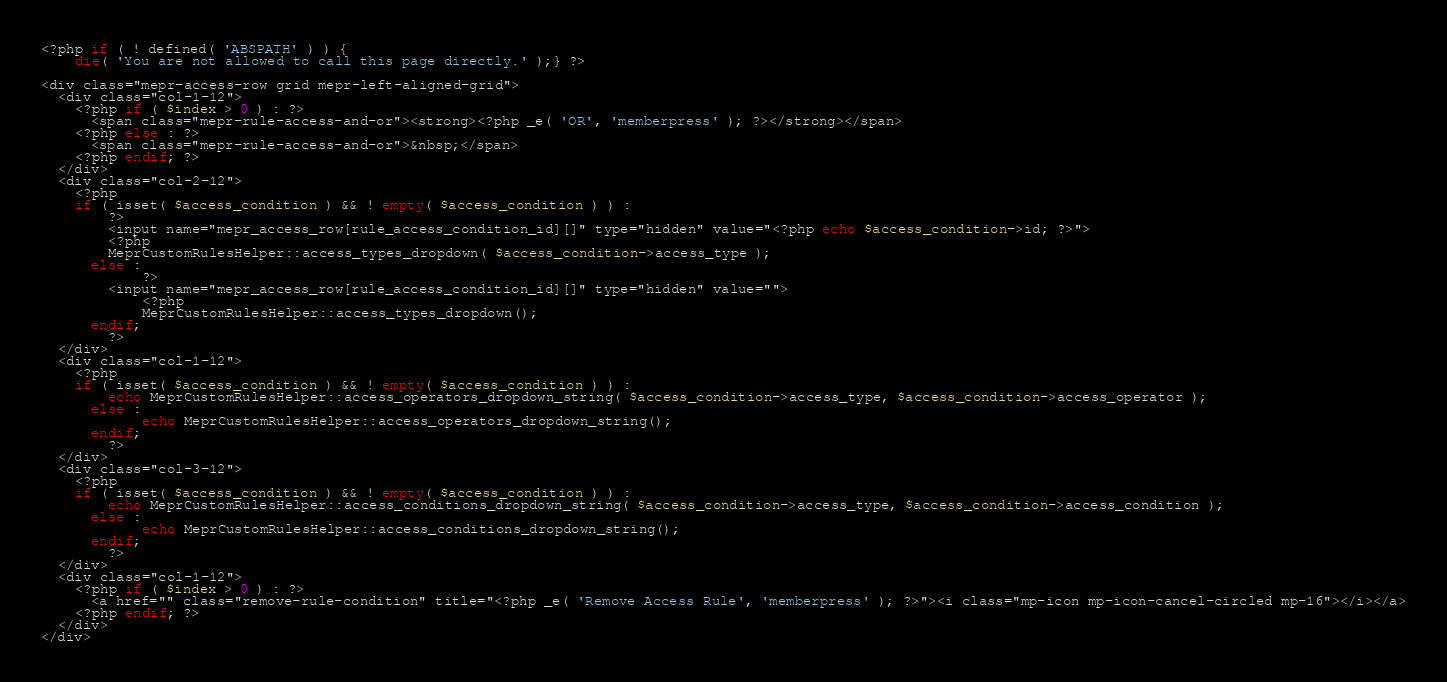<code> <loc_0><loc_0><loc_500><loc_500><_PHP_><?php if ( ! defined( 'ABSPATH' ) ) {
	die( 'You are not allowed to call this page directly.' );} ?>

<div class="mepr-access-row grid mepr-left-aligned-grid">
  <div class="col-1-12">
	<?php if ( $index > 0 ) : ?>
	  <span class="mepr-rule-access-and-or"><strong><?php _e( 'OR', 'memberpress' ); ?></strong></span>
	<?php else : ?>
	  <span class="mepr-rule-access-and-or">&nbsp;</span>
	<?php endif; ?>
  </div>
  <div class="col-2-12">
	<?php
	if ( isset( $access_condition ) && ! empty( $access_condition ) ) :
		?>
		<input name="mepr_access_row[rule_access_condition_id][]" type="hidden" value="<?php echo $access_condition->id; ?>">
		<?php
		MeprCustomRulesHelper::access_types_dropdown( $access_condition->access_type );
	  else :
			?>
		<input name="mepr_access_row[rule_access_condition_id][]" type="hidden" value="">
			<?php
			MeprCustomRulesHelper::access_types_dropdown();
	  endif;
		?>
  </div>
  <div class="col-1-12">
	<?php
	if ( isset( $access_condition ) && ! empty( $access_condition ) ) :
		echo MeprCustomRulesHelper::access_operators_dropdown_string( $access_condition->access_type, $access_condition->access_operator );
	  else :
			echo MeprCustomRulesHelper::access_operators_dropdown_string();
	  endif;
		?>
  </div>
  <div class="col-3-12">
	<?php
	if ( isset( $access_condition ) && ! empty( $access_condition ) ) :
		echo MeprCustomRulesHelper::access_conditions_dropdown_string( $access_condition->access_type, $access_condition->access_condition );
	  else :
			echo MeprCustomRulesHelper::access_conditions_dropdown_string();
	  endif;
		?>
  </div>
  <div class="col-1-12">
	<?php if ( $index > 0 ) : ?>
	  <a href="" class="remove-rule-condition" title="<?php _e( 'Remove Access Rule', 'memberpress' ); ?>"><i class="mp-icon mp-icon-cancel-circled mp-16"></i></a>
	<?php endif; ?>
  </div>
</div>
</code> 